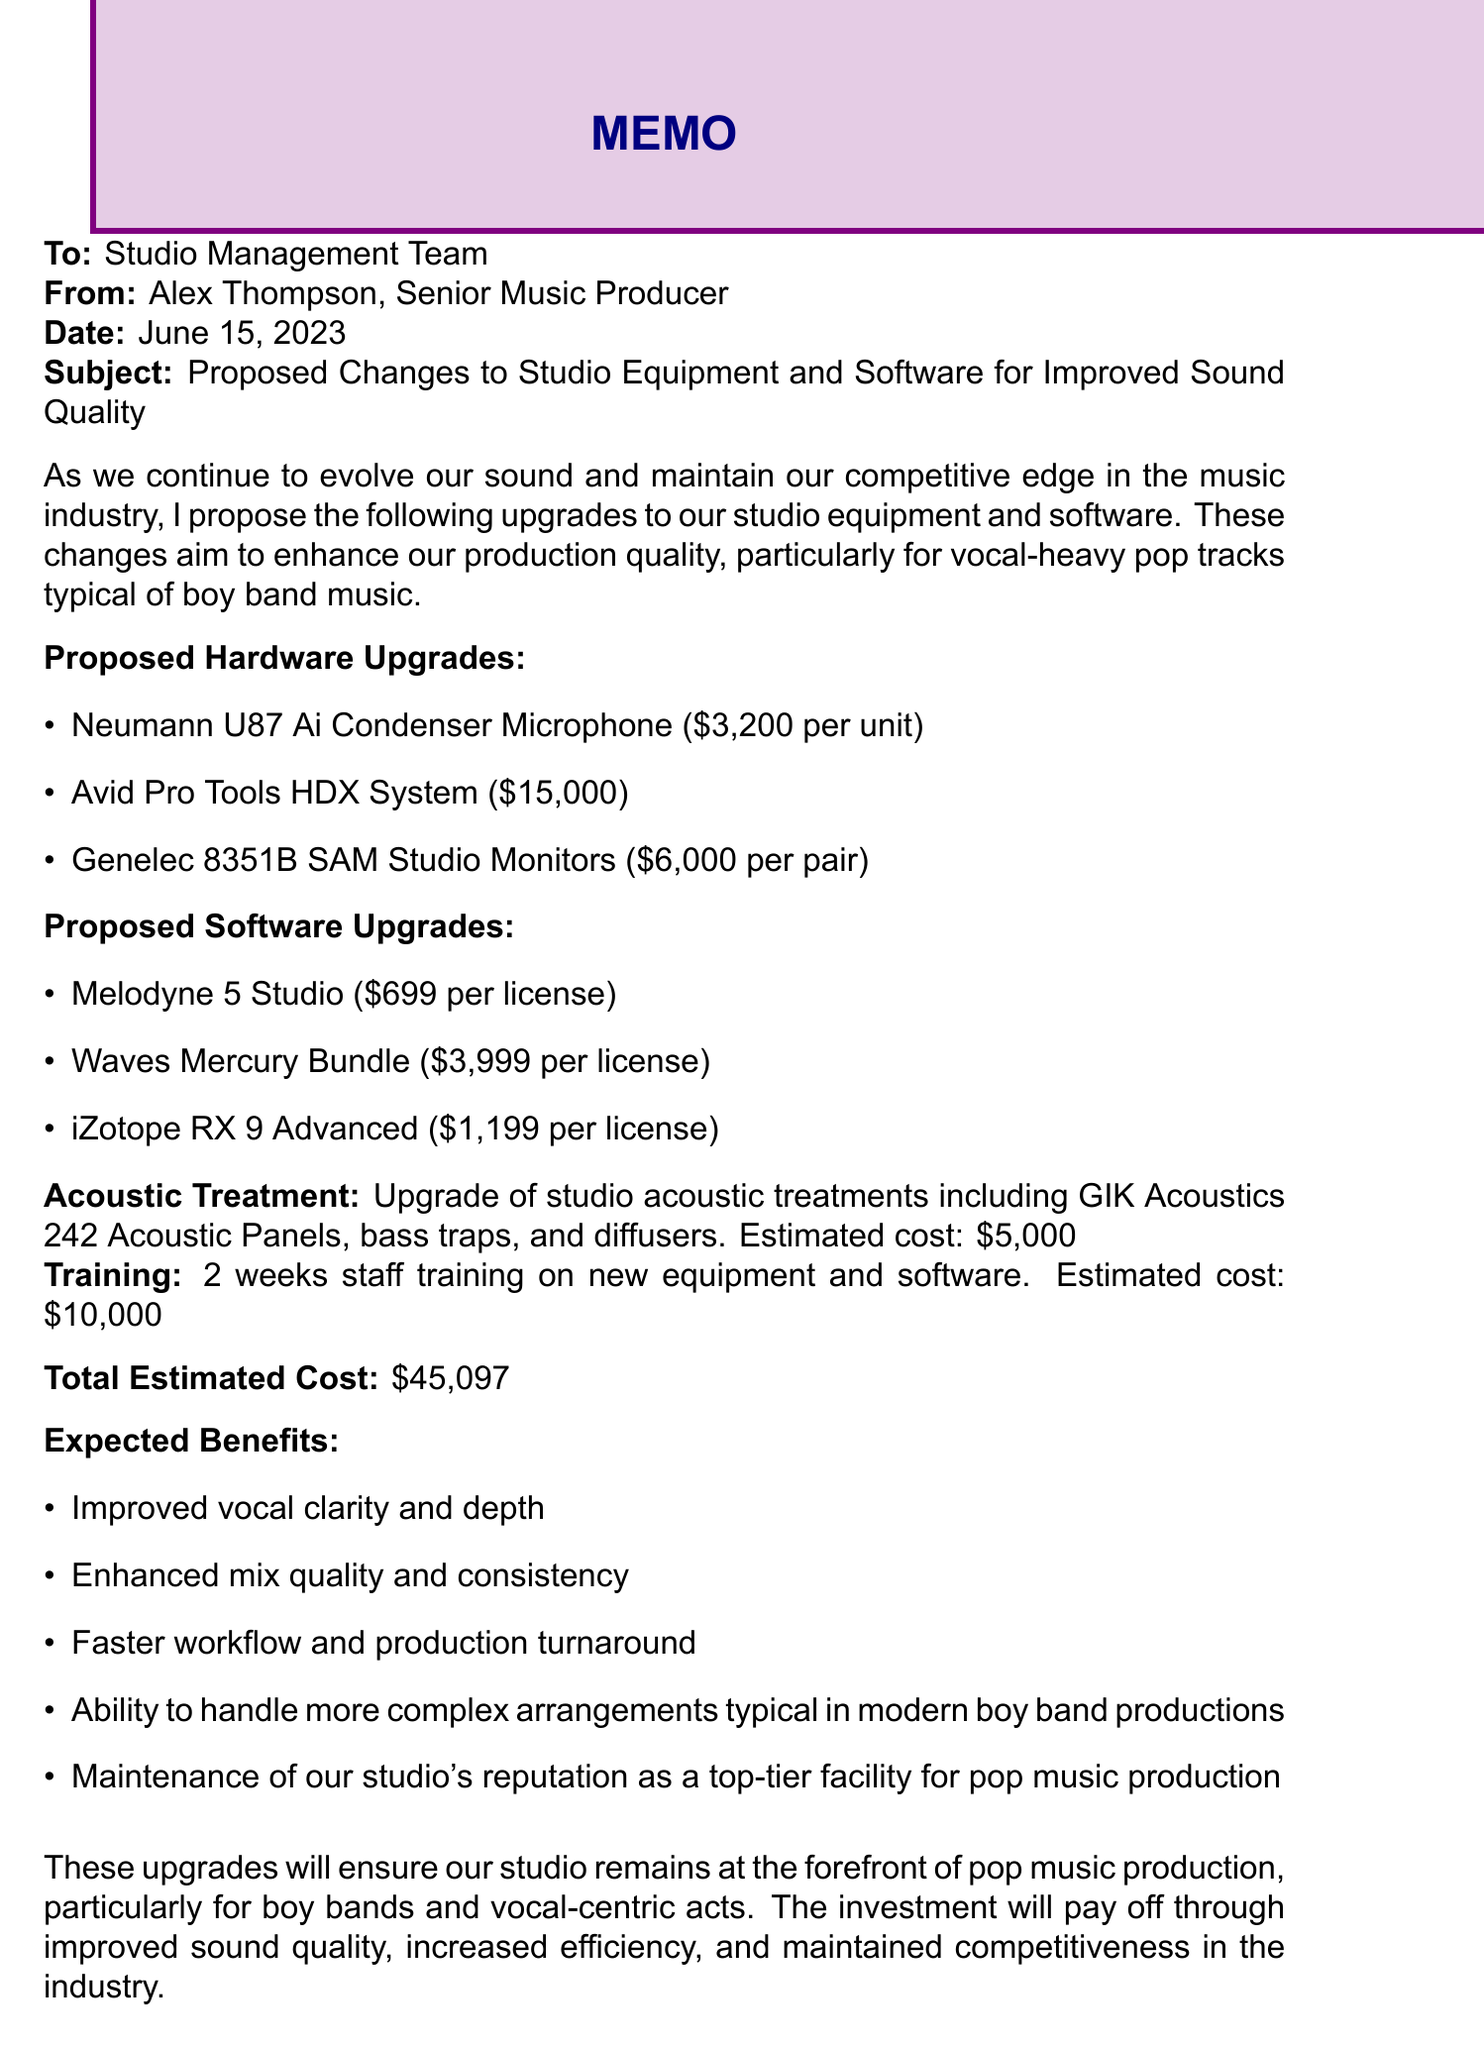What is the date of the memo? The date of the memo is stated at the top of the document.
Answer: June 15, 2023 What item is proposed for improved vocal clarity? The memo specifically lists a microphone that is standard for clear vocals.
Answer: Neumann U87 Ai Condenser Microphone What is the estimated cost of the Avid Pro Tools HDX System? The cost for this equipment is detailed in the hardware upgrades section.
Answer: $15,000 How long is the proposed staff training? The duration of the training is mentioned in the training section of the document.
Answer: 2 weeks What are the expected benefits of the proposed changes? A list of benefits is provided in the document, capturing the overall value of the investment.
Answer: Improved vocal clarity and depth What is the total estimated cost for all upgrades? The total cost is summarized at the end of the memo.
Answer: $45,097 What type of acoustic treatment is mentioned? The types of treatments to be upgraded are listed under the acoustic treatment section.
Answer: GIK Acoustics 242 Acoustic Panels What software is suggested for advanced pitch correction? The software with vocal editing capabilities is outlined in the software upgrades section.
Answer: Melodyne 5 Studio Why are the upgrades necessary? The introduction explains the reason behind the proposed changes.
Answer: Maintain competitive edge in the music industry 